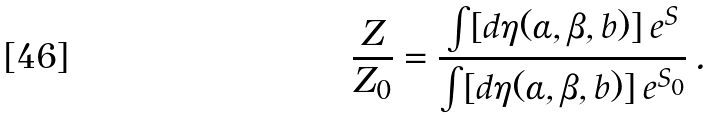<formula> <loc_0><loc_0><loc_500><loc_500>\frac { Z } { Z _ { 0 } } = \frac { \int [ d \eta ( \alpha , \beta , b ) ] \, e ^ { S } } { \int [ d \eta ( \alpha , \beta , b ) ] \, e ^ { S _ { 0 } } } \, .</formula> 